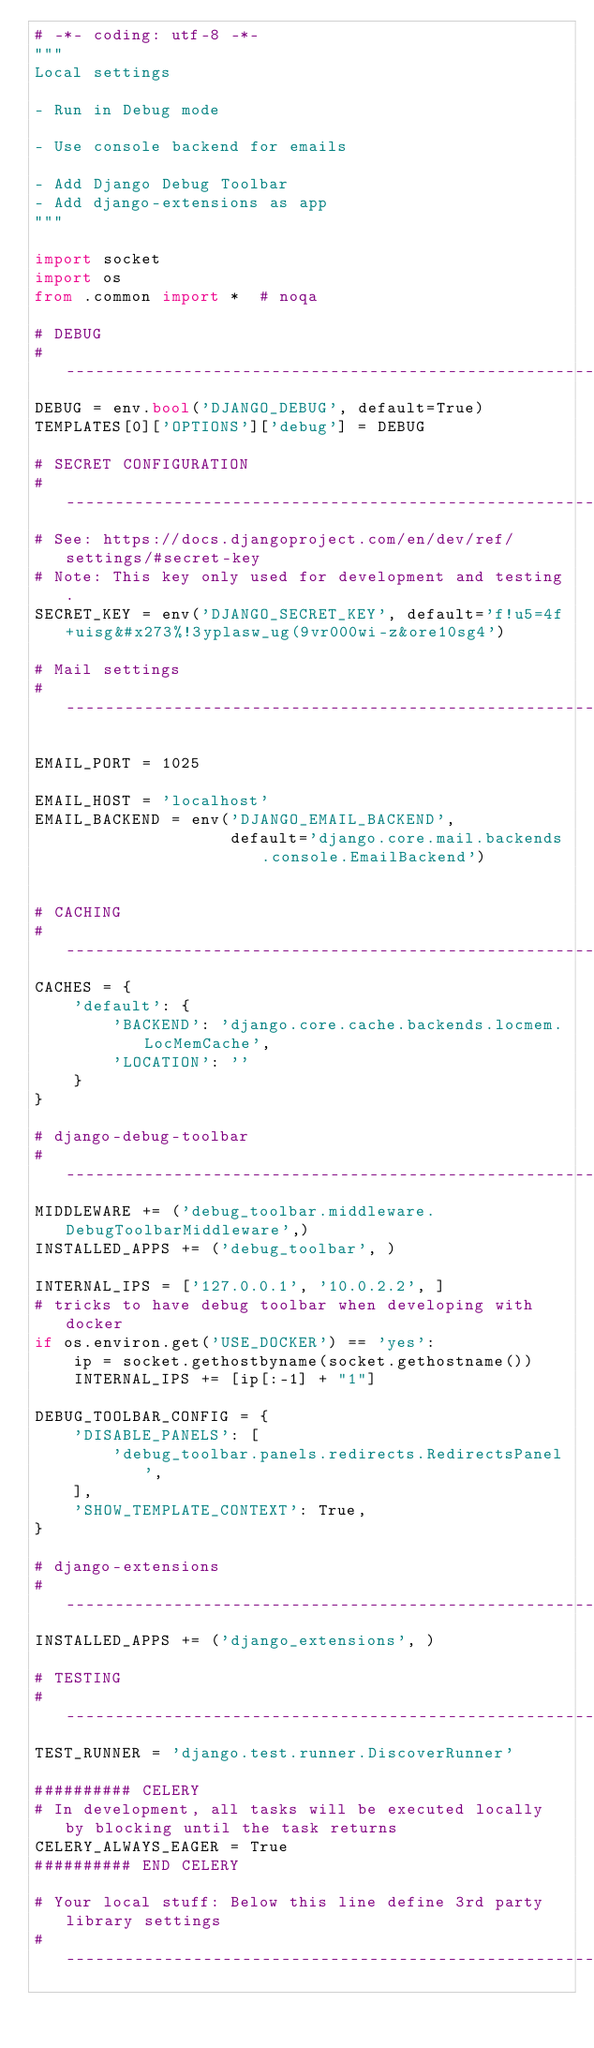Convert code to text. <code><loc_0><loc_0><loc_500><loc_500><_Python_># -*- coding: utf-8 -*-
"""
Local settings

- Run in Debug mode

- Use console backend for emails

- Add Django Debug Toolbar
- Add django-extensions as app
"""

import socket
import os
from .common import *  # noqa

# DEBUG
# ------------------------------------------------------------------------------
DEBUG = env.bool('DJANGO_DEBUG', default=True)
TEMPLATES[0]['OPTIONS']['debug'] = DEBUG

# SECRET CONFIGURATION
# ------------------------------------------------------------------------------
# See: https://docs.djangoproject.com/en/dev/ref/settings/#secret-key
# Note: This key only used for development and testing.
SECRET_KEY = env('DJANGO_SECRET_KEY', default='f!u5=4f+uisg&#x273%!3yplasw_ug(9vr000wi-z&ore10sg4')

# Mail settings
# ------------------------------------------------------------------------------

EMAIL_PORT = 1025

EMAIL_HOST = 'localhost'
EMAIL_BACKEND = env('DJANGO_EMAIL_BACKEND',
                    default='django.core.mail.backends.console.EmailBackend')


# CACHING
# ------------------------------------------------------------------------------
CACHES = {
    'default': {
        'BACKEND': 'django.core.cache.backends.locmem.LocMemCache',
        'LOCATION': ''
    }
}

# django-debug-toolbar
# ------------------------------------------------------------------------------
MIDDLEWARE += ('debug_toolbar.middleware.DebugToolbarMiddleware',)
INSTALLED_APPS += ('debug_toolbar', )

INTERNAL_IPS = ['127.0.0.1', '10.0.2.2', ]
# tricks to have debug toolbar when developing with docker
if os.environ.get('USE_DOCKER') == 'yes':
    ip = socket.gethostbyname(socket.gethostname())
    INTERNAL_IPS += [ip[:-1] + "1"]

DEBUG_TOOLBAR_CONFIG = {
    'DISABLE_PANELS': [
        'debug_toolbar.panels.redirects.RedirectsPanel',
    ],
    'SHOW_TEMPLATE_CONTEXT': True,
}

# django-extensions
# ------------------------------------------------------------------------------
INSTALLED_APPS += ('django_extensions', )

# TESTING
# ------------------------------------------------------------------------------
TEST_RUNNER = 'django.test.runner.DiscoverRunner'

########## CELERY
# In development, all tasks will be executed locally by blocking until the task returns
CELERY_ALWAYS_EAGER = True
########## END CELERY

# Your local stuff: Below this line define 3rd party library settings
# ------------------------------------------------------------------------------
</code> 